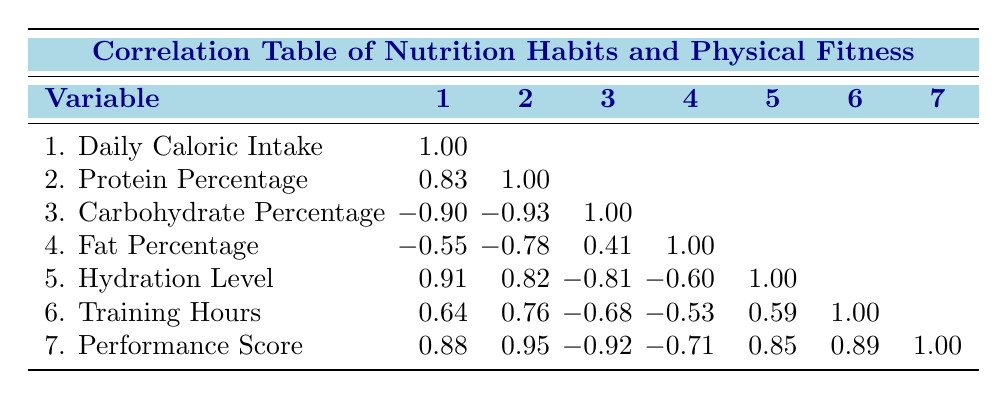What is the correlation between daily caloric intake and performance score? The correlation coefficient between these two variables is 0.88, indicating a strong positive relationship; as daily caloric intake increases, so does the performance score of the archers.
Answer: 0.88 What percentage of carbohydrates do Lee Dong-wook's nutrition habits consist of? Referring to the data for Lee Dong-wook, the carbohydrate percentage is listed as 45.
Answer: 45 Is there a positive correlation between protein percentage and training hours? The correlation coefficient between protein percentage and training hours is 0.76, which shows a positive correlation; as protein intake increases, training hours also tend to increase.
Answer: Yes What is the average fat percentage of the archers in this table? The fat percentages are 20, 20, 20, 20, and 18; summing these yields 98, and dividing by 5 gives an average of 19.6.
Answer: 19.6 Which archer has the highest hydration level, and what is that value? From the table, Lee Dong-wook has the highest hydration level listed at 3.5 liters.
Answer: 3.5 liters What is the difference in performance score between Kim Tae-woo and Choi Sun-young? Kim Tae-woo's performance score is 92, while Choi Sun-young's is 75. The difference is calculated as 92 - 75 = 17.
Answer: 17 Is the protein percentage of Park Min-hee higher than that of Choi Sun-young? Park Min-hee has a protein percentage of 28, while Choi Sun-young's is 25. Since 28 is greater than 25, the statement is true.
Answer: Yes How does the correlation between daily caloric intake and hydration level compare to the correlation between fat percentage and training hours? The correlation between daily caloric intake and hydration level is 0.91 (strong positive), while the correlation between fat percentage and training hours is -0.53 (moderate negative); hence, they differ significantly in direction and strength.
Answer: They differ significantly 